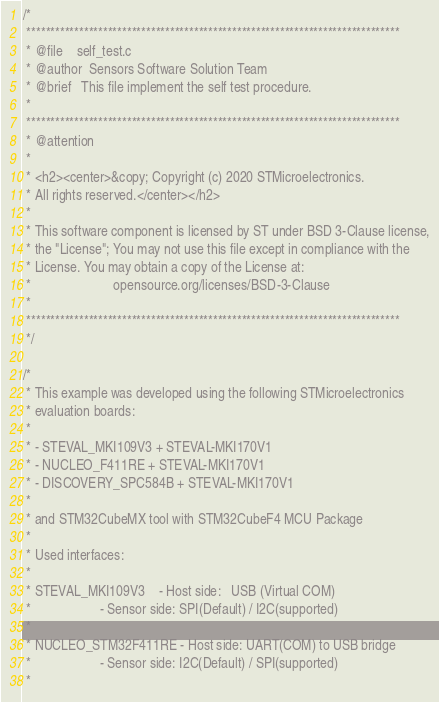Convert code to text. <code><loc_0><loc_0><loc_500><loc_500><_C_>/*
 ******************************************************************************
 * @file    self_test.c
 * @author  Sensors Software Solution Team
 * @brief   This file implement the self test procedure.
 *
 ******************************************************************************
 * @attention
 *
 * <h2><center>&copy; Copyright (c) 2020 STMicroelectronics.
 * All rights reserved.</center></h2>
 *
 * This software component is licensed by ST under BSD 3-Clause license,
 * the "License"; You may not use this file except in compliance with the
 * License. You may obtain a copy of the License at:
 *                        opensource.org/licenses/BSD-3-Clause
 *
 ******************************************************************************
 */

/*
 * This example was developed using the following STMicroelectronics
 * evaluation boards:
 *
 * - STEVAL_MKI109V3 + STEVAL-MKI170V1
 * - NUCLEO_F411RE + STEVAL-MKI170V1
 * - DISCOVERY_SPC584B + STEVAL-MKI170V1
 *
 * and STM32CubeMX tool with STM32CubeF4 MCU Package
 *
 * Used interfaces:
 *
 * STEVAL_MKI109V3    - Host side:   USB (Virtual COM)
 *                    - Sensor side: SPI(Default) / I2C(supported)
 *
 * NUCLEO_STM32F411RE - Host side: UART(COM) to USB bridge
 *                    - Sensor side: I2C(Default) / SPI(supported)
 *</code> 